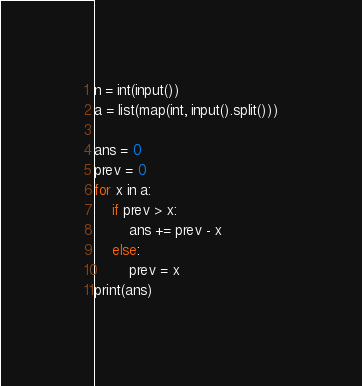<code> <loc_0><loc_0><loc_500><loc_500><_Python_>n = int(input())
a = list(map(int, input().split()))

ans = 0
prev = 0
for x in a:
    if prev > x:
        ans += prev - x
    else:
        prev = x
print(ans)
</code> 